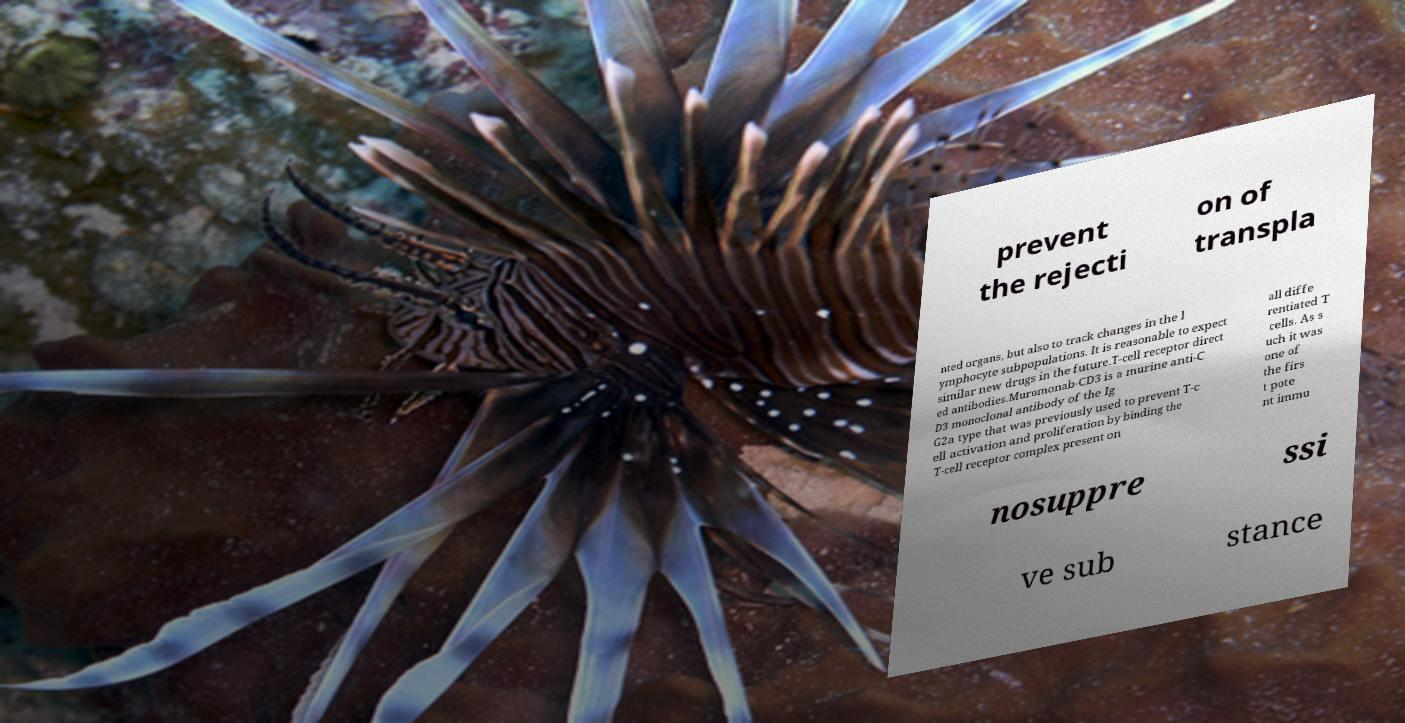Can you accurately transcribe the text from the provided image for me? prevent the rejecti on of transpla nted organs, but also to track changes in the l ymphocyte subpopulations. It is reasonable to expect similar new drugs in the future.T-cell receptor direct ed antibodies.Muromonab-CD3 is a murine anti-C D3 monoclonal antibody of the Ig G2a type that was previously used to prevent T-c ell activation and proliferation by binding the T-cell receptor complex present on all diffe rentiated T cells. As s uch it was one of the firs t pote nt immu nosuppre ssi ve sub stance 